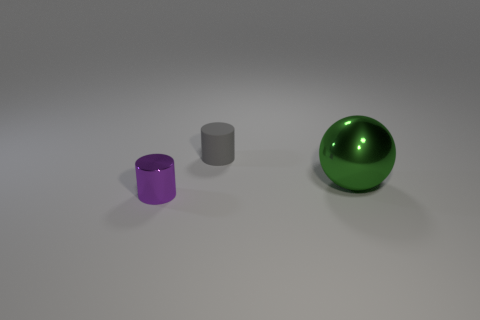Add 1 small brown metal things. How many objects exist? 4 Subtract all spheres. How many objects are left? 2 Subtract 0 gray cubes. How many objects are left? 3 Subtract all small purple cylinders. Subtract all tiny purple cylinders. How many objects are left? 1 Add 3 matte cylinders. How many matte cylinders are left? 4 Add 3 big objects. How many big objects exist? 4 